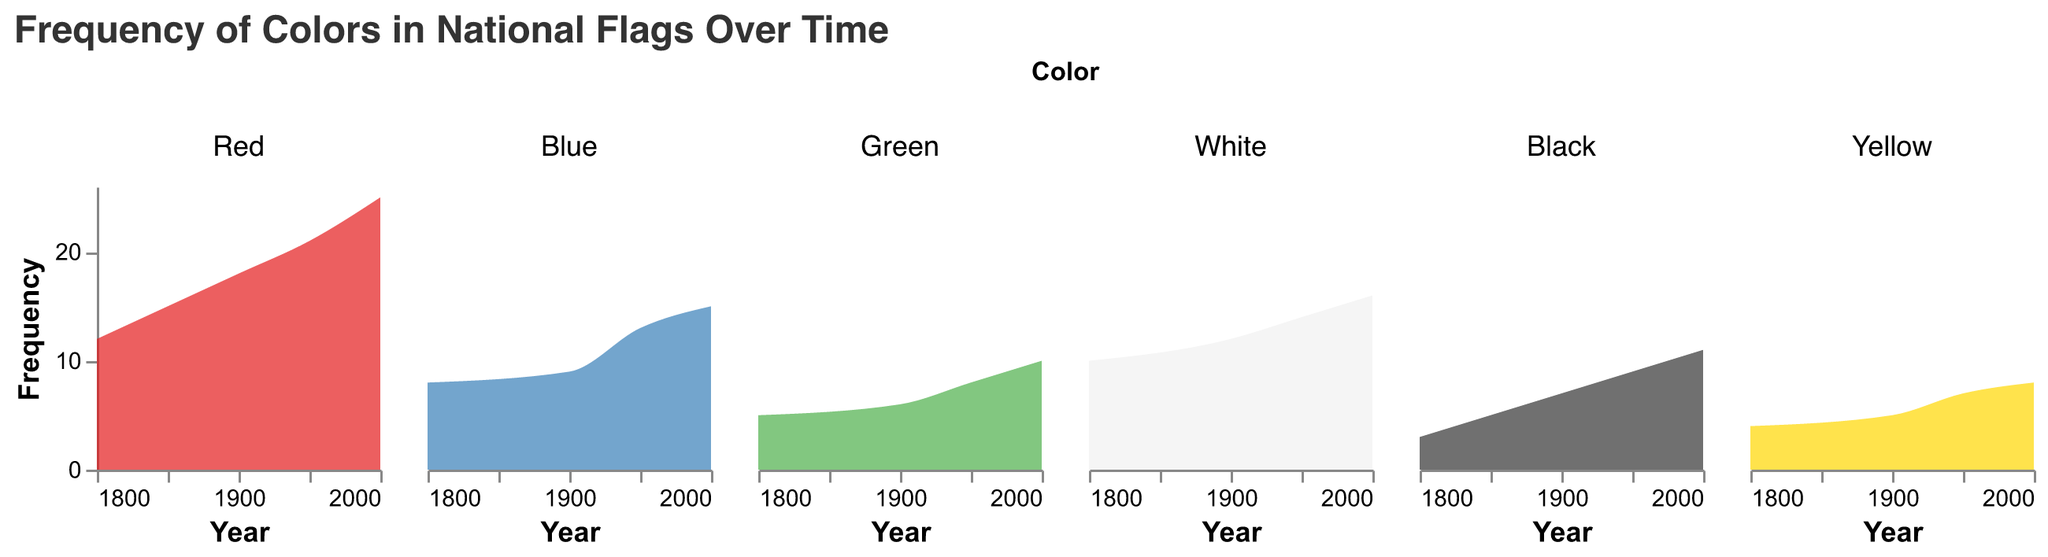What is the title of the figure? The title is clearly shown at the top of the figure. It reads "Frequency of Colors in National Flags Over Time".
Answer: Frequency of Colors in National Flags Over Time Which color had the highest frequency in national flags in the year 2000? By looking at the subplot for each color, the area under the curve is the largest for red in 2000.
Answer: Red How did the frequency of blue change from 1800 to 2000? Trace the blue line across the years. Blue starts at 8 in 1800 and increases to 15 by 2000.
Answer: Increase by 7 Compare the frequency of green and black in the year 1950. Which one had a higher frequency? In 1950, the subplot for green shows a frequency of 8, while the subplot for black shows 9.
Answer: Black What is the sum of the frequencies for yellow in the years 1800 and 1950? Sum the frequency of yellow in 1800 (4) and 1950 (7): 4 + 7 = 11.
Answer: 11 How many distinct colors are analyzed in the figure? Each subplot represents a distinct color. Counting the subplots gives us 6 colors.
Answer: 6 Between which years did white experience the highest growth in frequency? By observing the changes in the area under the curve for white, the largest growth is from 1800 to 2000 (10 to 16).
Answer: 1800 to 2000 Which two colors had a frequency of 5 in the year 1800? Looking at the 1800 tick mark on the frequency axis, green and yellow both have frequencies of 5.
Answer: Green and Yellow Describe the trend of red's frequency over the years. The red subplot shows an increasing trend: From 12 in 1800 to 18 in 1900, then to 21 in 1950, and finally 25 in 2000.
Answer: Increasing trend 